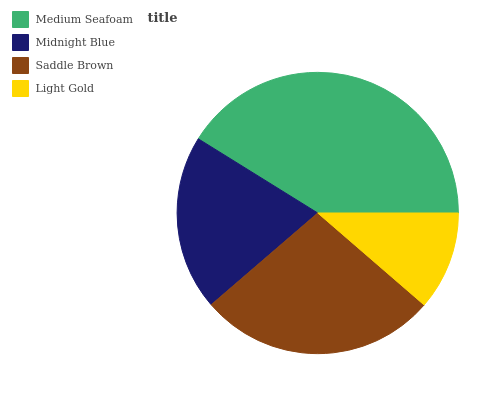Is Light Gold the minimum?
Answer yes or no. Yes. Is Medium Seafoam the maximum?
Answer yes or no. Yes. Is Midnight Blue the minimum?
Answer yes or no. No. Is Midnight Blue the maximum?
Answer yes or no. No. Is Medium Seafoam greater than Midnight Blue?
Answer yes or no. Yes. Is Midnight Blue less than Medium Seafoam?
Answer yes or no. Yes. Is Midnight Blue greater than Medium Seafoam?
Answer yes or no. No. Is Medium Seafoam less than Midnight Blue?
Answer yes or no. No. Is Saddle Brown the high median?
Answer yes or no. Yes. Is Midnight Blue the low median?
Answer yes or no. Yes. Is Midnight Blue the high median?
Answer yes or no. No. Is Medium Seafoam the low median?
Answer yes or no. No. 